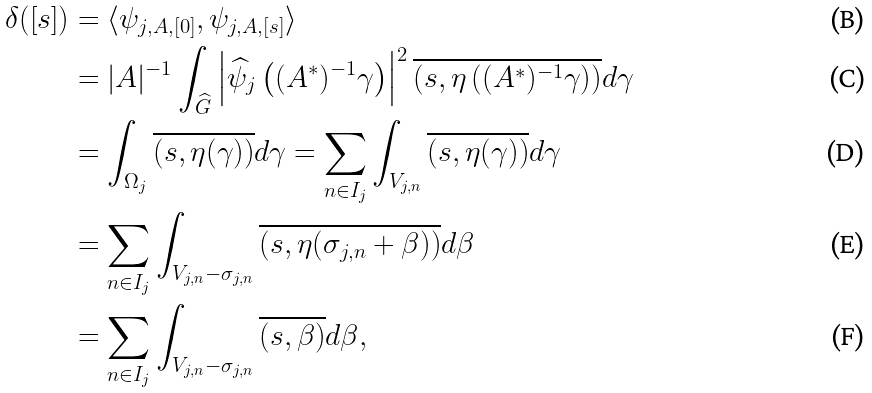<formula> <loc_0><loc_0><loc_500><loc_500>\delta ( [ s ] ) & = \langle \psi _ { j , A , [ 0 ] } , \psi _ { j , A , [ s ] } \rangle \\ & = | A | ^ { - 1 } \int _ { \widehat { G } } \left | \widehat { \psi } _ { j } \left ( ( A ^ { \ast } ) ^ { - 1 } \gamma \right ) \right | ^ { 2 } \overline { \left ( s , \eta \left ( ( A ^ { \ast } ) ^ { - 1 } \gamma \right ) \right ) } d \gamma \\ & = \int _ { \Omega _ { j } } \overline { ( s , \eta ( \gamma ) ) } d \gamma = \sum _ { n \in I _ { j } } \int _ { V _ { j , n } } \overline { ( s , \eta ( \gamma ) ) } d \gamma \\ & = \sum _ { n \in I _ { j } } \int _ { V _ { j , n } - \sigma _ { j , n } } \overline { ( s , \eta ( \sigma _ { j , n } + \beta ) ) } d \beta \\ & = \sum _ { n \in I _ { j } } \int _ { V _ { j , n } - \sigma _ { j , n } } \overline { ( s , \beta ) } d \beta ,</formula> 